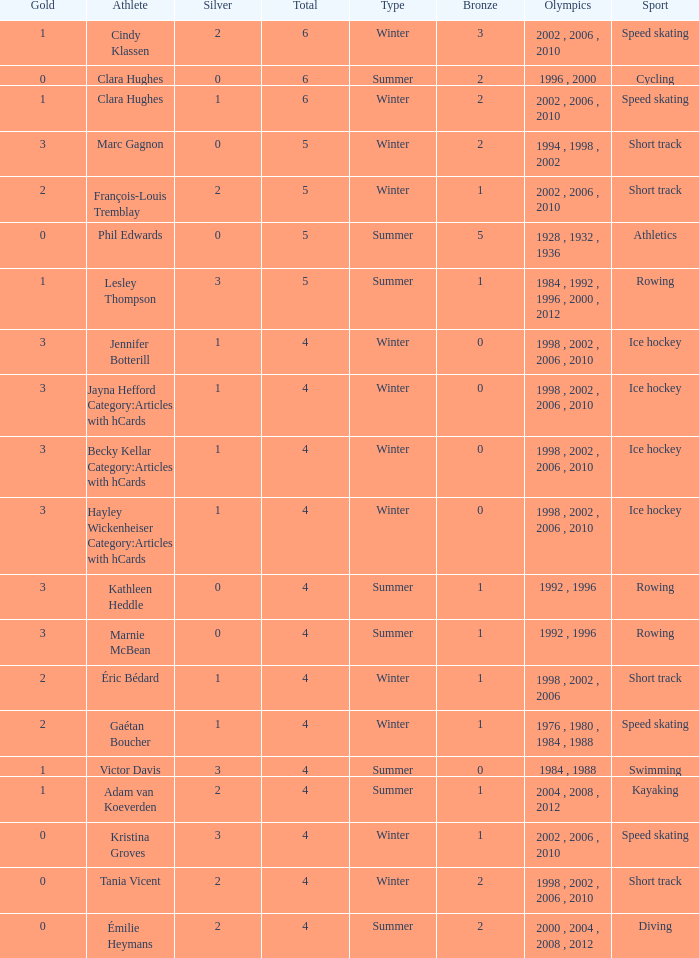What is the average gold of the winter athlete with 1 bronze, less than 3 silver, and less than 4 total medals? None. 